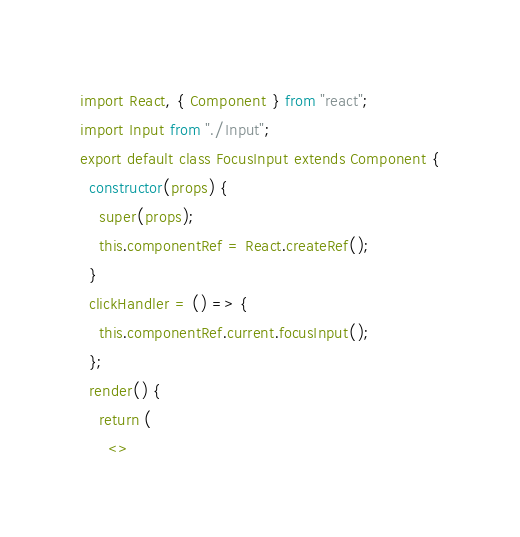Convert code to text. <code><loc_0><loc_0><loc_500><loc_500><_JavaScript_>import React, { Component } from "react";
import Input from "./Input";
export default class FocusInput extends Component {
  constructor(props) {
    super(props);
    this.componentRef = React.createRef();
  }
  clickHandler = () => {
    this.componentRef.current.focusInput();
  };
  render() {
    return (
      <></code> 